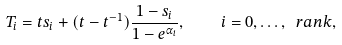<formula> <loc_0><loc_0><loc_500><loc_500>T _ { i } = t s _ { i } + ( t - t ^ { - 1 } ) \frac { 1 - s _ { i } } { 1 - e ^ { \alpha _ { i } } } , \quad i = 0 , \dots , \ r a n k ,</formula> 